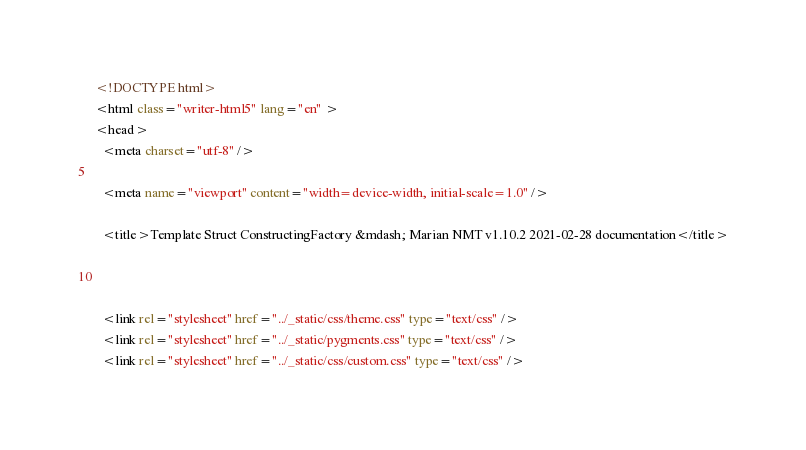Convert code to text. <code><loc_0><loc_0><loc_500><loc_500><_HTML_>

<!DOCTYPE html>
<html class="writer-html5" lang="en" >
<head>
  <meta charset="utf-8" />
  
  <meta name="viewport" content="width=device-width, initial-scale=1.0" />
  
  <title>Template Struct ConstructingFactory &mdash; Marian NMT v1.10.2 2021-02-28 documentation</title>
  

  
  <link rel="stylesheet" href="../_static/css/theme.css" type="text/css" />
  <link rel="stylesheet" href="../_static/pygments.css" type="text/css" />
  <link rel="stylesheet" href="../_static/css/custom.css" type="text/css" /></code> 